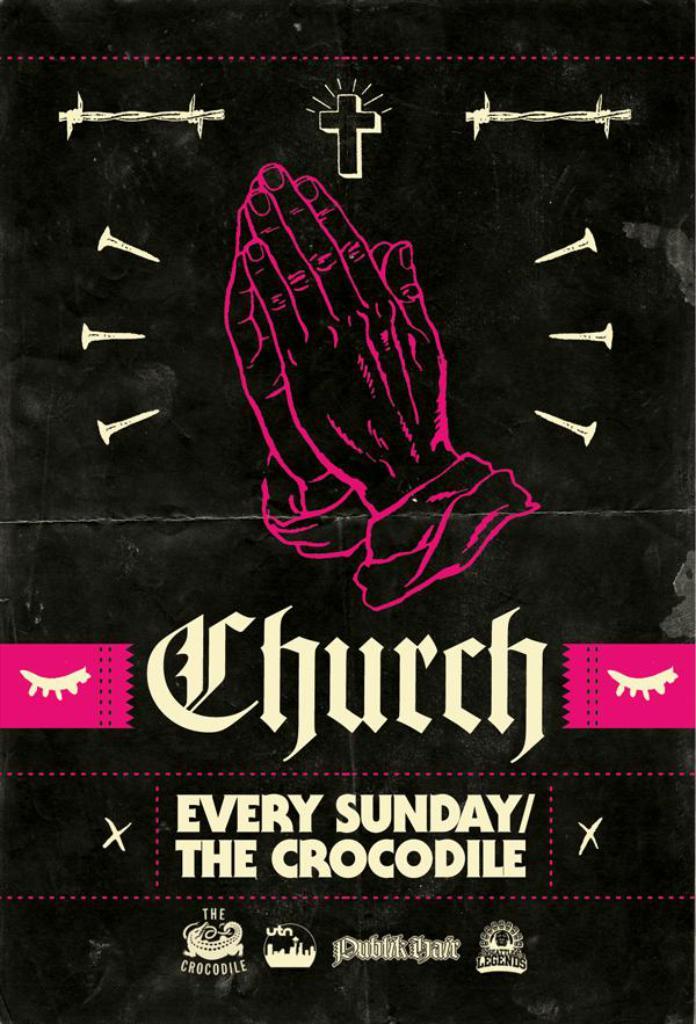Which day of the week is mentioned?
Keep it short and to the point. Sunday. What is written in the largest font?
Your answer should be very brief. Church. 